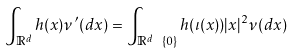<formula> <loc_0><loc_0><loc_500><loc_500>\int _ { \mathbb { R } ^ { d } } h ( x ) \nu ^ { \prime } ( d x ) = \int _ { \mathbb { R } ^ { d } \ \{ 0 \} } h ( \iota ( x ) ) | x | ^ { 2 } \nu ( d x )</formula> 